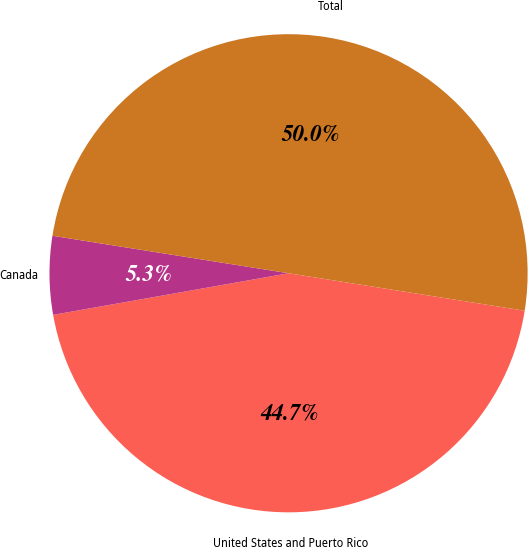Convert chart to OTSL. <chart><loc_0><loc_0><loc_500><loc_500><pie_chart><fcel>United States and Puerto Rico<fcel>Canada<fcel>Total<nl><fcel>44.71%<fcel>5.29%<fcel>50.0%<nl></chart> 